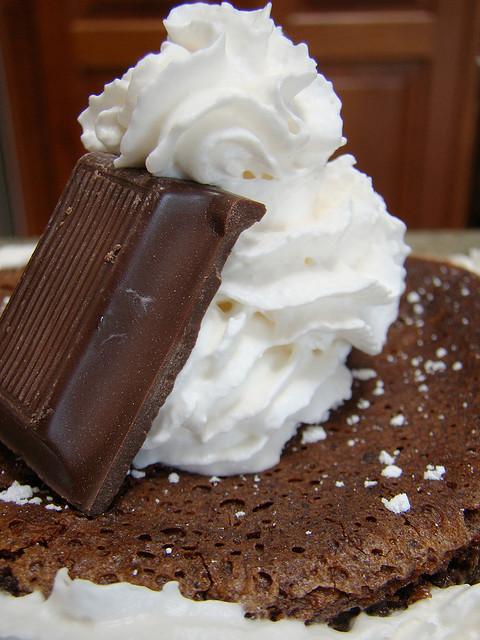Name one material in this photo that cannot be eaten by a human being?
Write a very short answer. Wood. What is the white stuff called?
Write a very short answer. Whipped cream. Is that chocolate?
Keep it brief. Yes. 